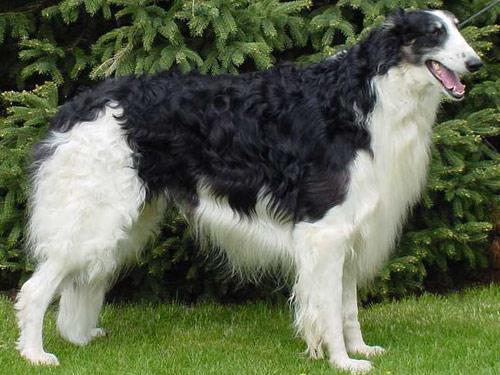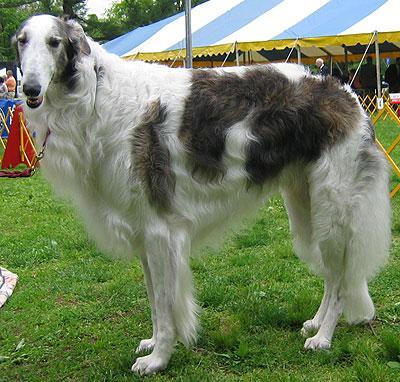The first image is the image on the left, the second image is the image on the right. Given the left and right images, does the statement "The hounds in the two images face in the general direction toward each other." hold true? Answer yes or no. Yes. 